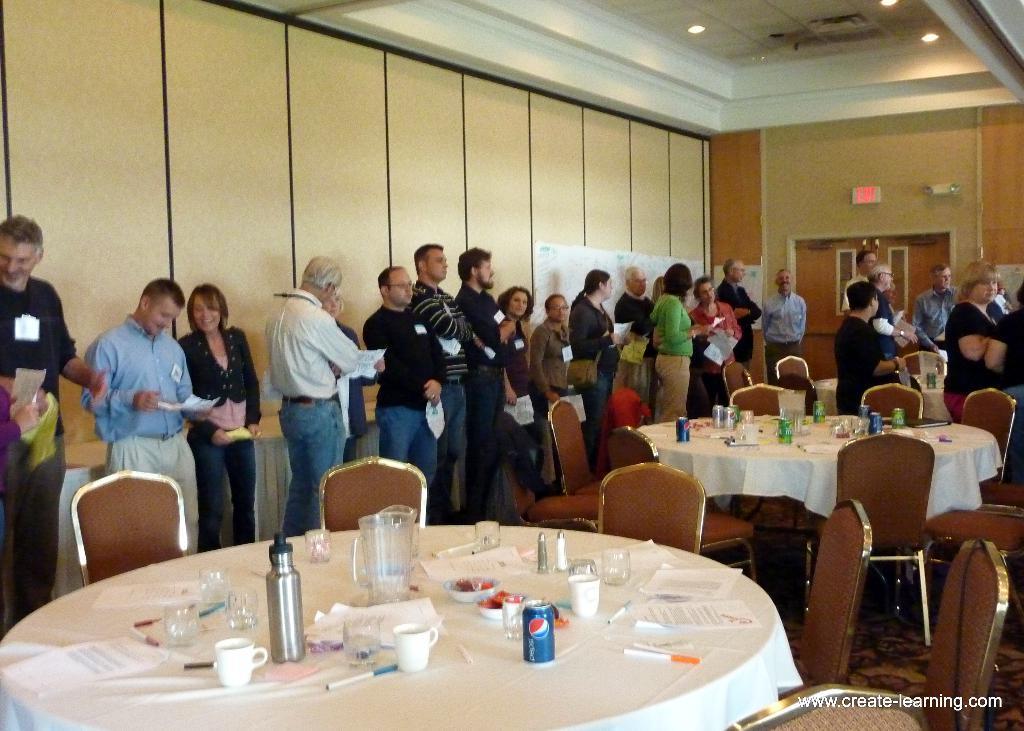Can you describe this image briefly? In the image we have a group of people who are standing on the wall side and in front of the people we have a few table and a white colour cloth on the table. On the table we have tin can a bottle and see all the stuff on it and here we have a couple of chairs at the side of the table 